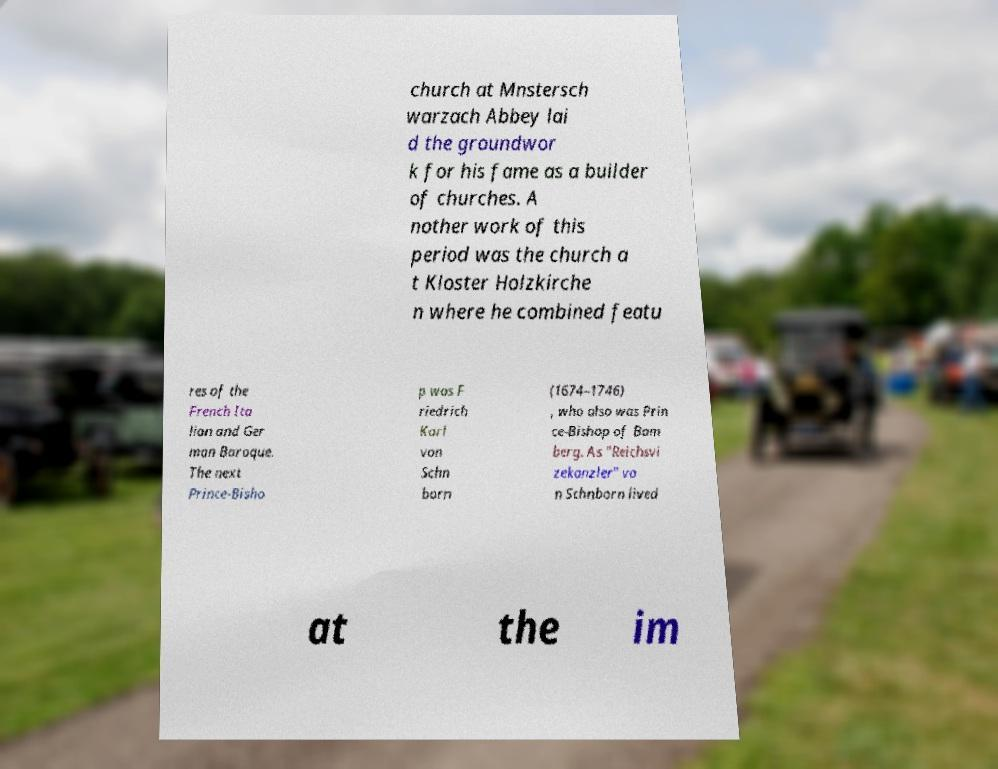There's text embedded in this image that I need extracted. Can you transcribe it verbatim? church at Mnstersch warzach Abbey lai d the groundwor k for his fame as a builder of churches. A nother work of this period was the church a t Kloster Holzkirche n where he combined featu res of the French Ita lian and Ger man Baroque. The next Prince-Bisho p was F riedrich Karl von Schn born (1674–1746) , who also was Prin ce-Bishop of Bam berg. As "Reichsvi zekanzler" vo n Schnborn lived at the im 